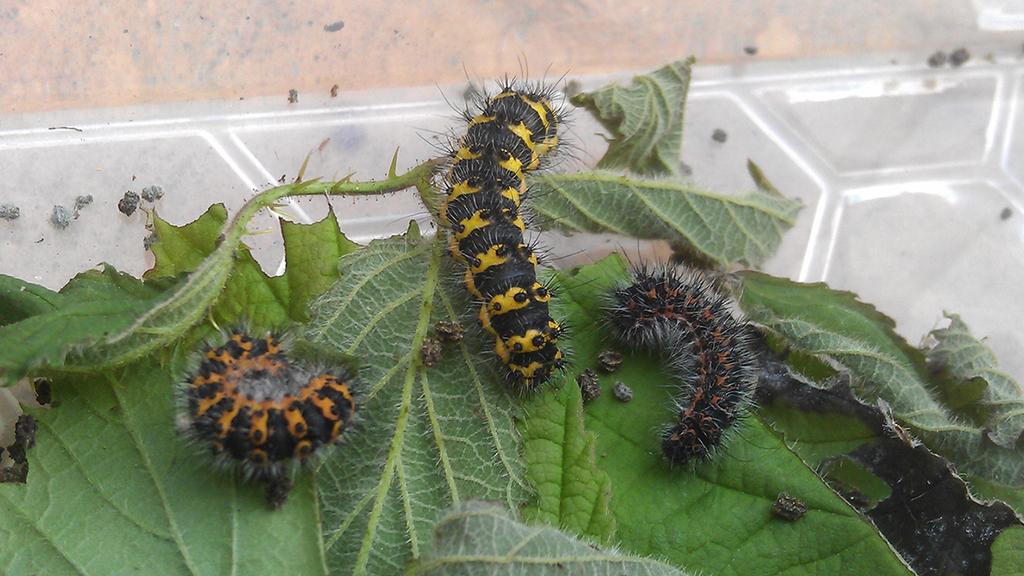What type of creatures are present in the image? There are insects in the image. What colors can be seen on the insects? The insects have orange, black, and yellow colors. Where are the insects located in the image? The insects are on green leaves. What is the color of the surface visible in the image? The surface visible in the image is cream, grey, and white. What type of scene is depicted in the bedroom in the image? There is no bedroom or scene present in the image; it features insects on green leaves with a cream, grey, and white surface visible. 